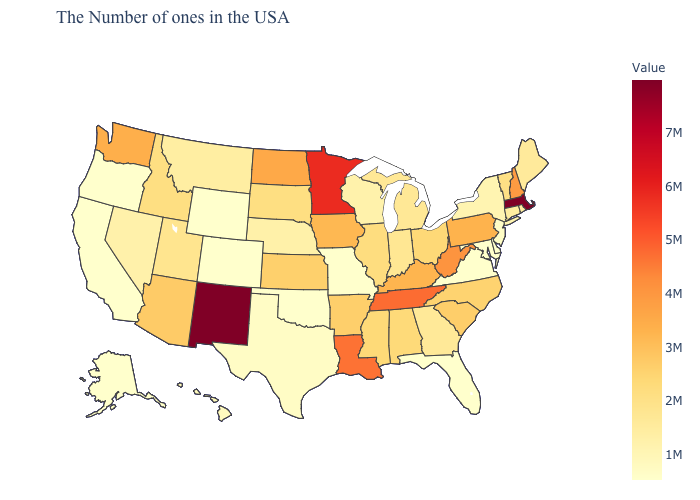Which states have the lowest value in the Northeast?
Be succinct. New Jersey. Among the states that border New York , does Massachusetts have the highest value?
Write a very short answer. Yes. Does the map have missing data?
Keep it brief. No. Does the map have missing data?
Write a very short answer. No. Which states hav the highest value in the MidWest?
Answer briefly. Minnesota. Does Utah have the highest value in the USA?
Quick response, please. No. 